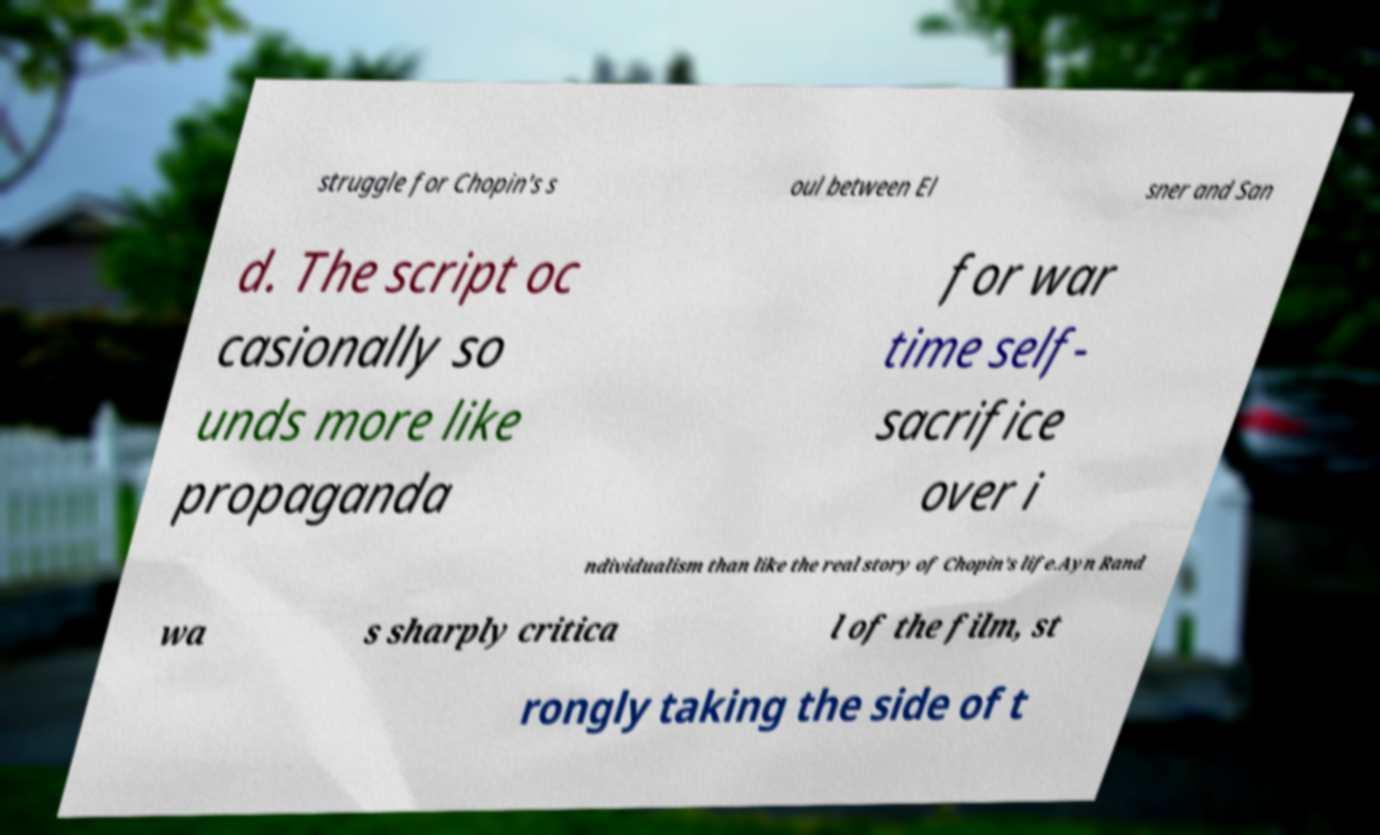Please identify and transcribe the text found in this image. struggle for Chopin's s oul between El sner and San d. The script oc casionally so unds more like propaganda for war time self- sacrifice over i ndividualism than like the real story of Chopin's life.Ayn Rand wa s sharply critica l of the film, st rongly taking the side of t 